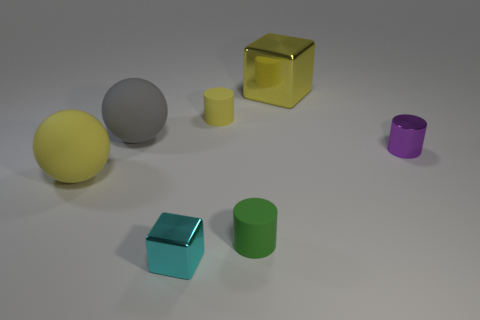Subtract 1 cylinders. How many cylinders are left? 2 Add 2 tiny yellow cylinders. How many objects exist? 9 Subtract all cubes. How many objects are left? 5 Subtract all gray balls. Subtract all cyan things. How many objects are left? 5 Add 3 small green matte cylinders. How many small green matte cylinders are left? 4 Add 6 cyan things. How many cyan things exist? 7 Subtract 0 brown cylinders. How many objects are left? 7 